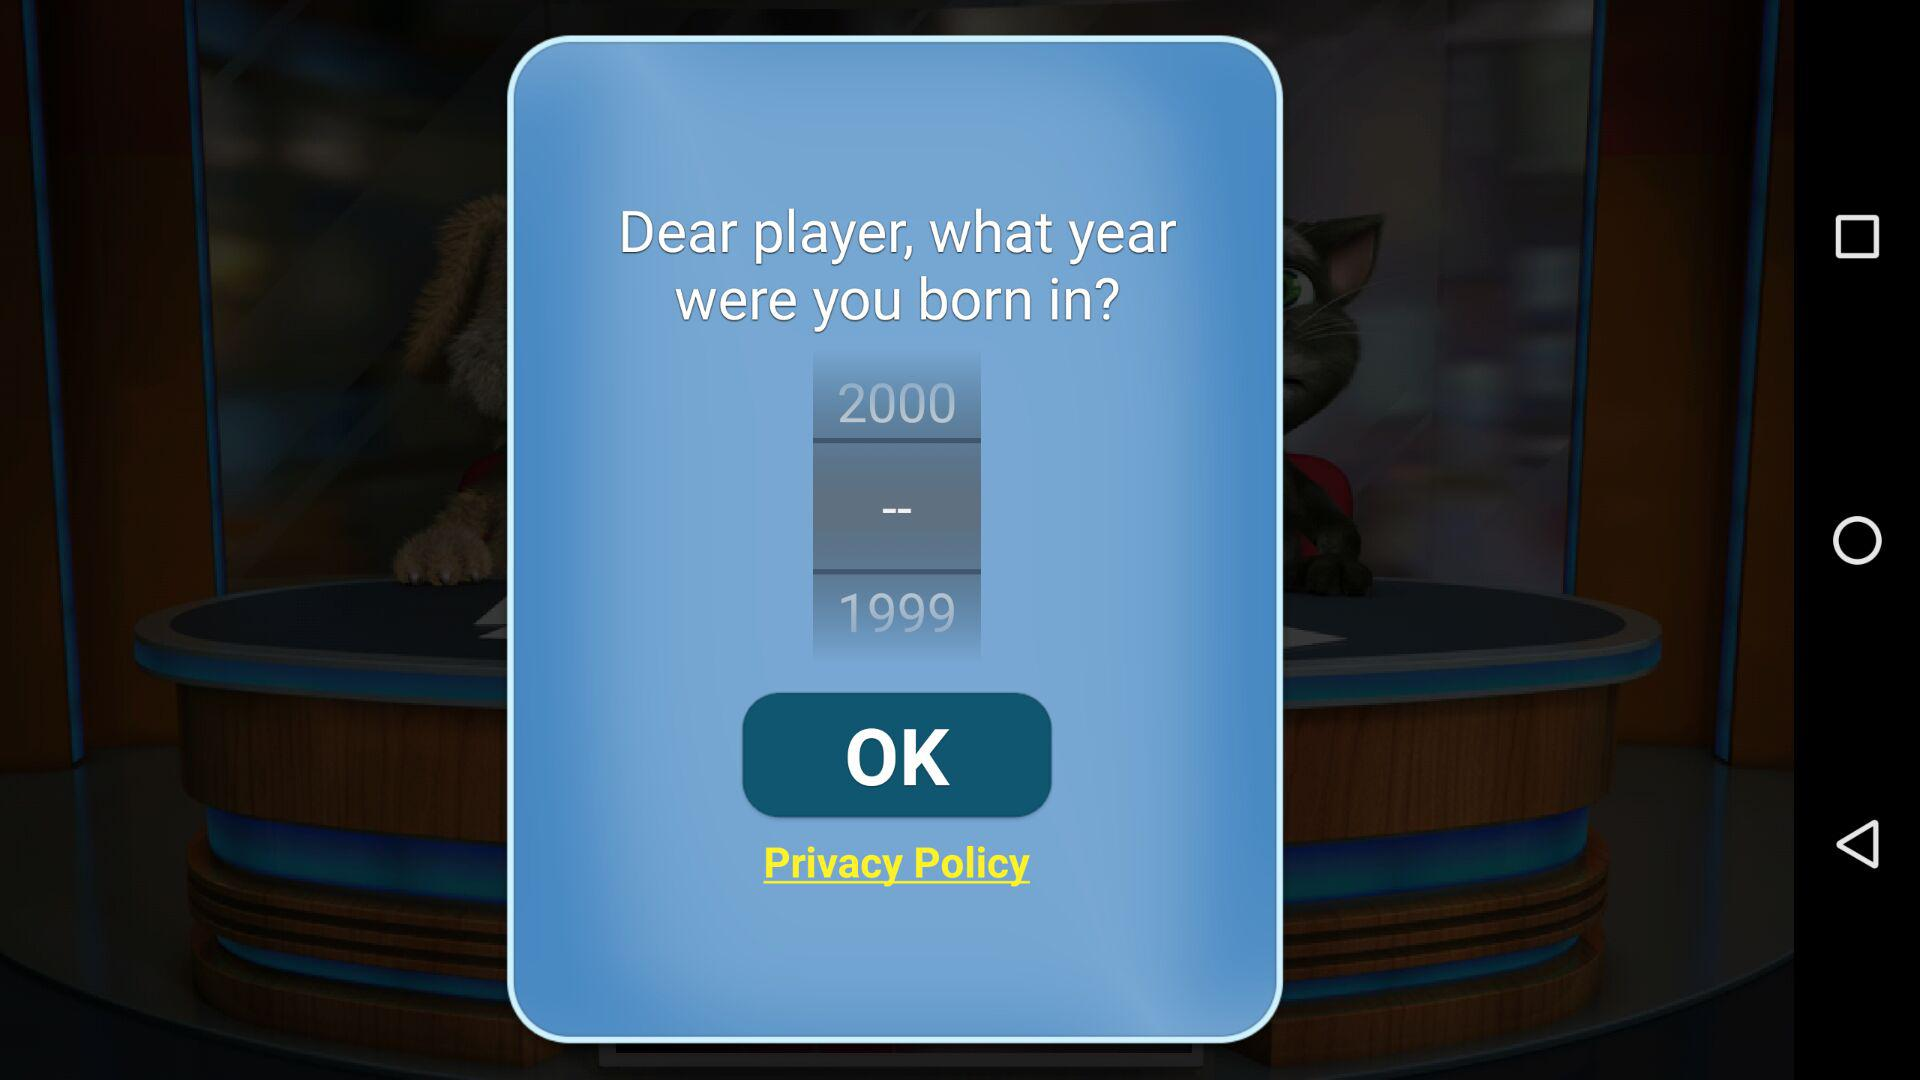What is the difference in years between the oldest and youngest birth years available?
Answer the question using a single word or phrase. 1 